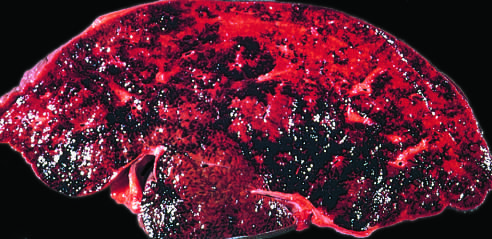what has thrombosis of the major hepatic veins caused?
Answer the question using a single word or phrase. Severe hepatic congestion 